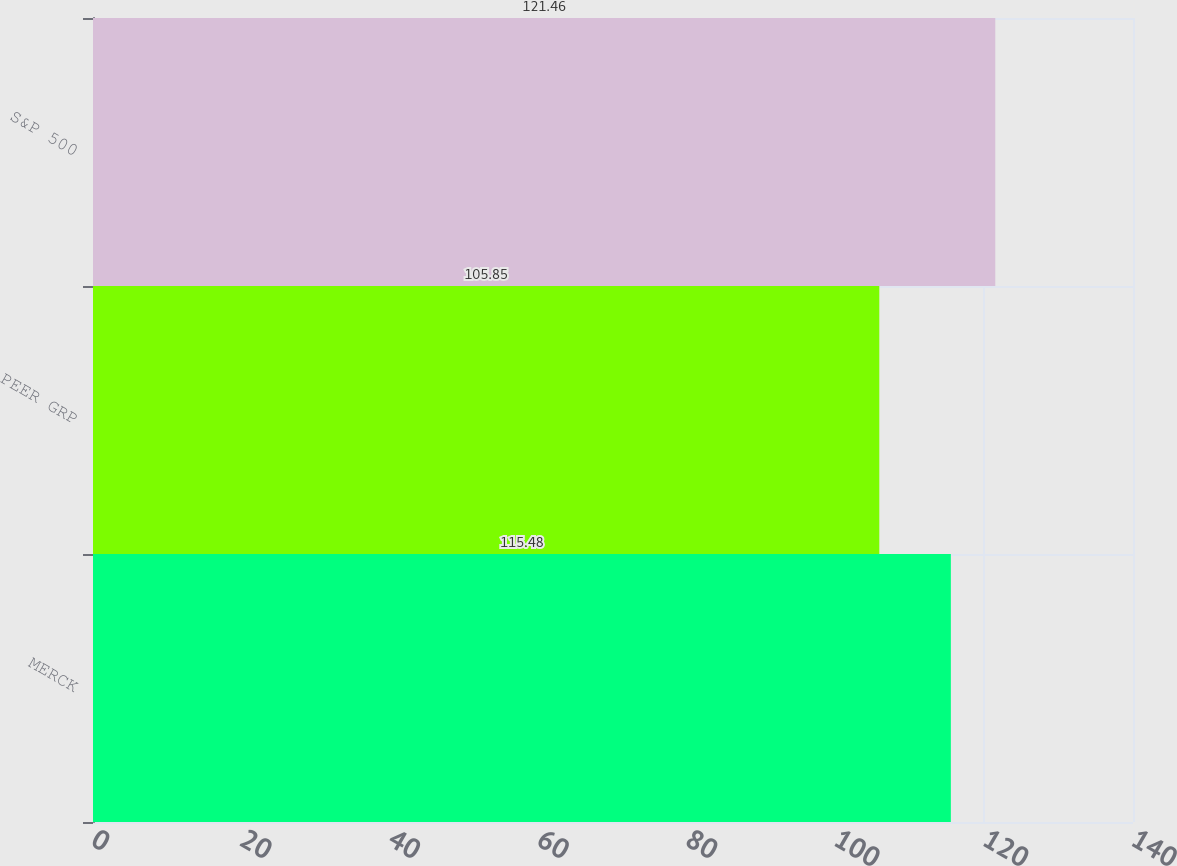Convert chart to OTSL. <chart><loc_0><loc_0><loc_500><loc_500><bar_chart><fcel>MERCK<fcel>PEER GRP<fcel>S&P 500<nl><fcel>115.48<fcel>105.85<fcel>121.46<nl></chart> 